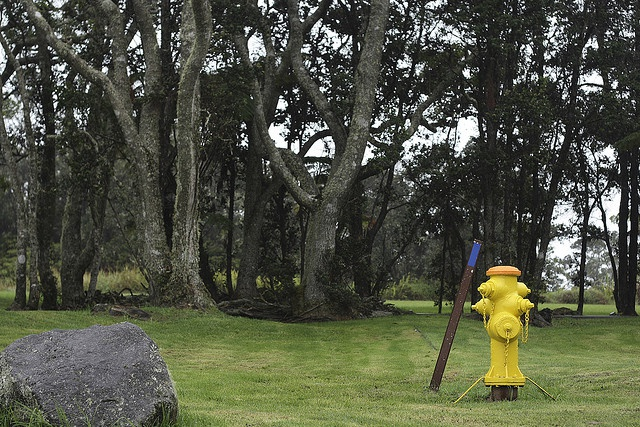Describe the objects in this image and their specific colors. I can see a fire hydrant in black, gold, khaki, and olive tones in this image. 